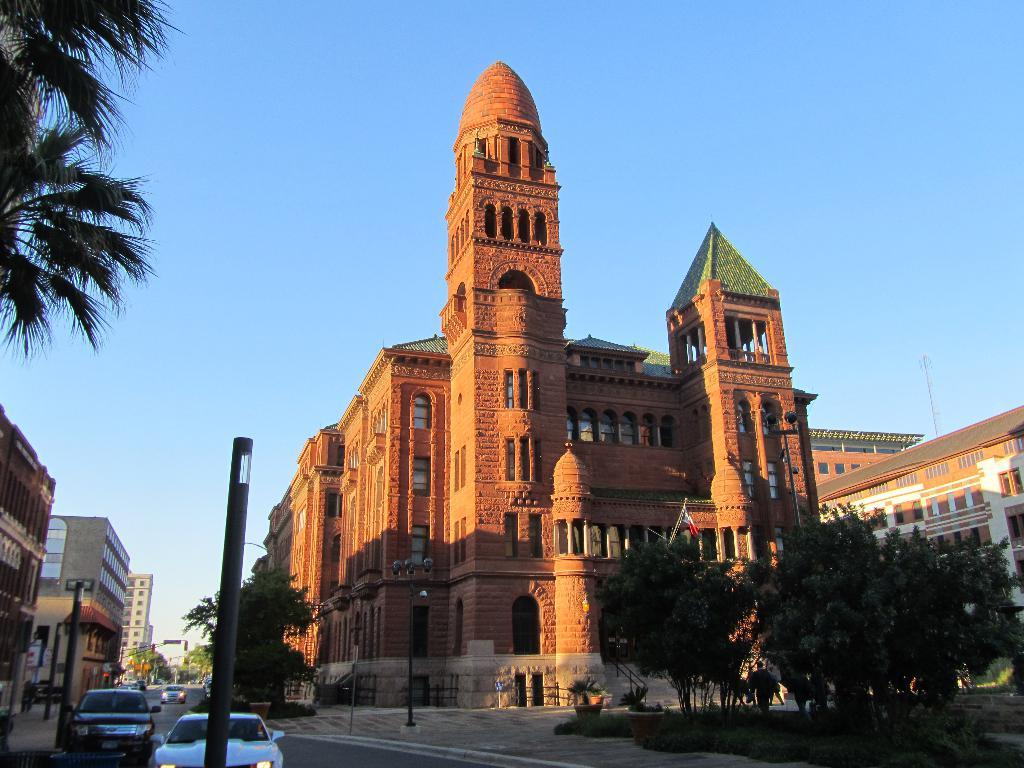What type of structures can be seen in the image? There are buildings in the image. What else can be seen in the image besides the buildings? There are trees in the image. What is happening on the road in front of the buildings? Cars are passing on the road in front of the buildings. How many thrones are visible in the image? There are no thrones present in the image. Are the sisters sitting on the grass in the image? There is no mention of sisters or grass in the image, so it cannot be determined from the provided facts. 